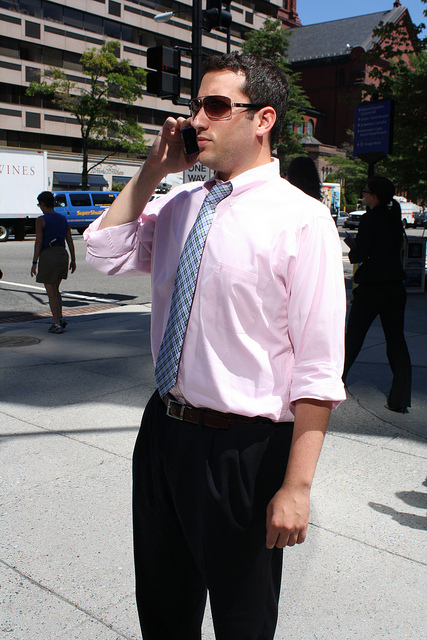Please transcribe the text in this image. WINES ONE WAY 